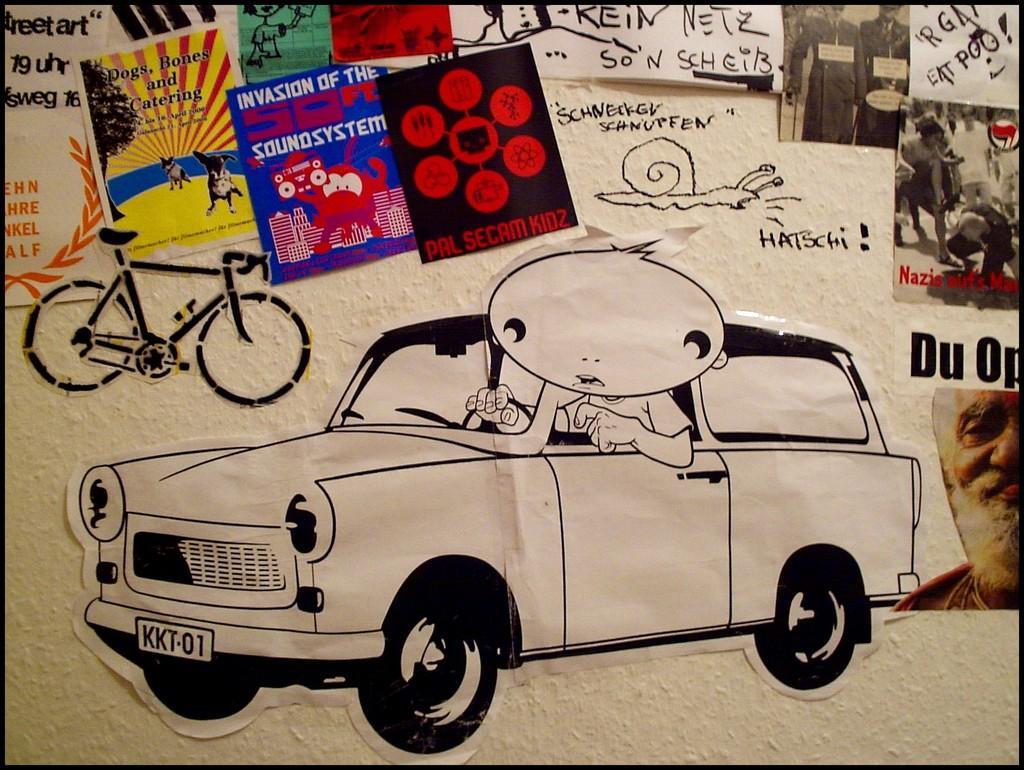How would you summarize this image in a sentence or two? In this image we can see posts on the wall. On the posters we can see pictures and text written on it. 